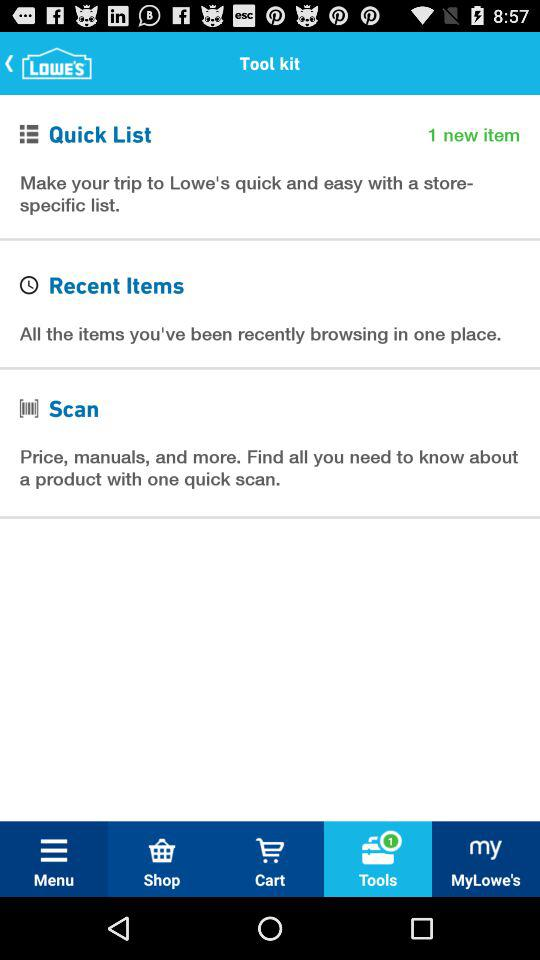How many new items are in the quick list? There is 1 new item in the quick list. 